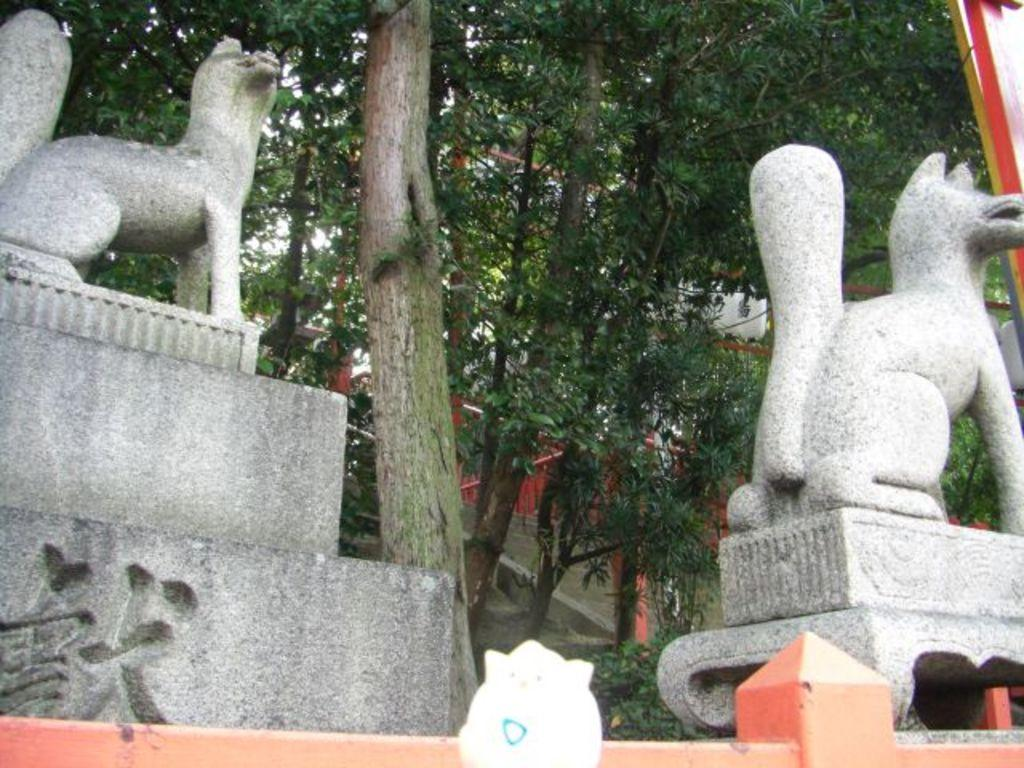What objects are present in the image? There are statues in the image. What can be seen in the background of the image? There are trees in the background of the image. What type of texture can be seen on the ice in the image? There is no ice present in the image, so it is not possible to determine the texture of any ice. What is the stick used for in the image? There is no stick present in the image. 